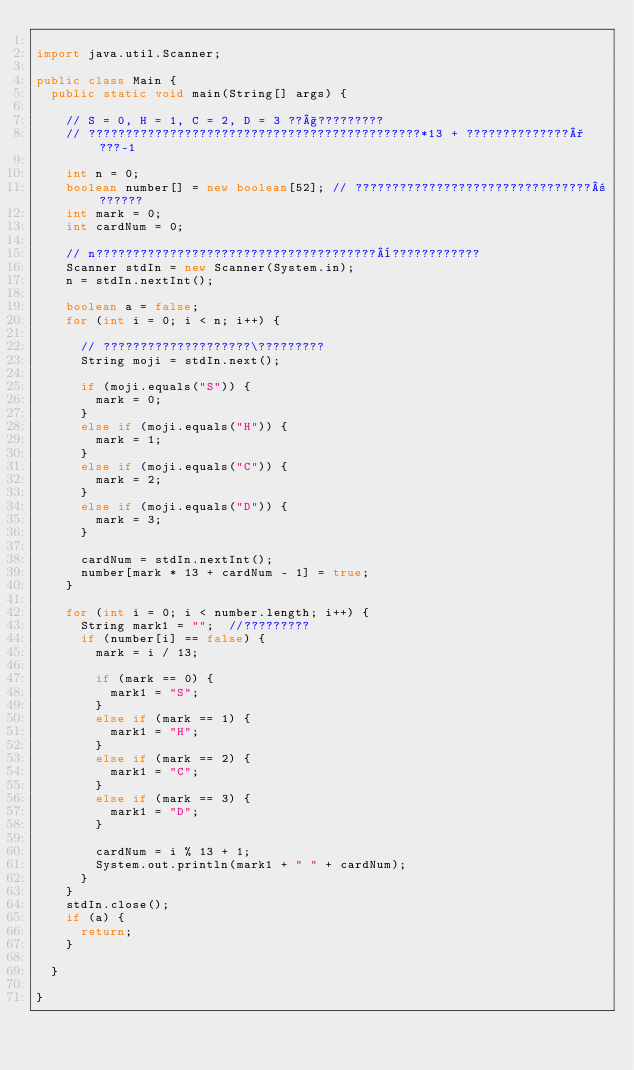<code> <loc_0><loc_0><loc_500><loc_500><_Java_>
import java.util.Scanner;

public class Main {
	public static void main(String[] args) {

		// S = 0, H = 1, C = 2, D = 3 ??§?????????
		// ?????????????????????????????????????????????*13 + ??????????????°???-1

		int n = 0;
		boolean number[] = new boolean[52]; // ????????????????????????????????±??????
		int mark = 0;
		int cardNum = 0;

		// n??????????????????????????????????????¨????????????
		Scanner stdIn = new Scanner(System.in);
		n = stdIn.nextInt();

		boolean a = false;
		for (int i = 0; i < n; i++) {

			// ????????????????????\?????????
			String moji = stdIn.next();

			if (moji.equals("S")) {
				mark = 0;
			}
			else if (moji.equals("H")) {
				mark = 1;
			}
			else if (moji.equals("C")) {
				mark = 2;
			}
			else if (moji.equals("D")) {
				mark = 3;
			}

			cardNum = stdIn.nextInt();
			number[mark * 13 + cardNum - 1] = true;
		}

		for (int i = 0; i < number.length; i++) {
			String mark1 = "";	//?????????
			if (number[i] == false) {
				mark = i / 13;

				if (mark == 0) {
					mark1 = "S";
				}
				else if (mark == 1) {
					mark1 = "H";
				}
				else if (mark == 2) {
					mark1 = "C";
				}
				else if (mark == 3) {
					mark1 = "D";
				}

				cardNum = i % 13 + 1;
				System.out.println(mark1 + " " + cardNum);
			}
		}
		stdIn.close();
		if (a) {
			return;
		}

	}

}</code> 